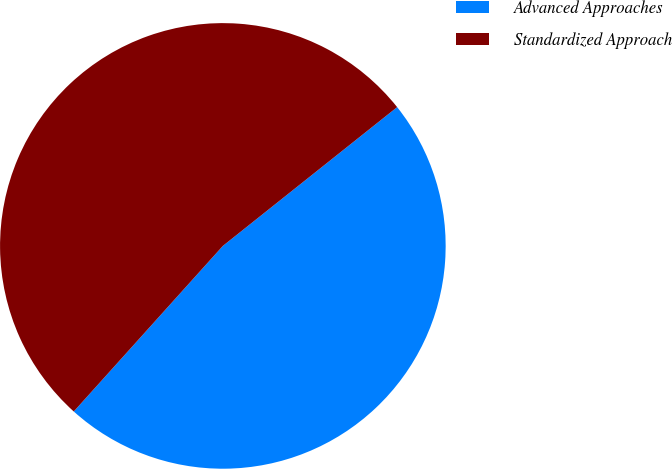Convert chart. <chart><loc_0><loc_0><loc_500><loc_500><pie_chart><fcel>Advanced Approaches<fcel>Standardized Approach<nl><fcel>47.37%<fcel>52.63%<nl></chart> 